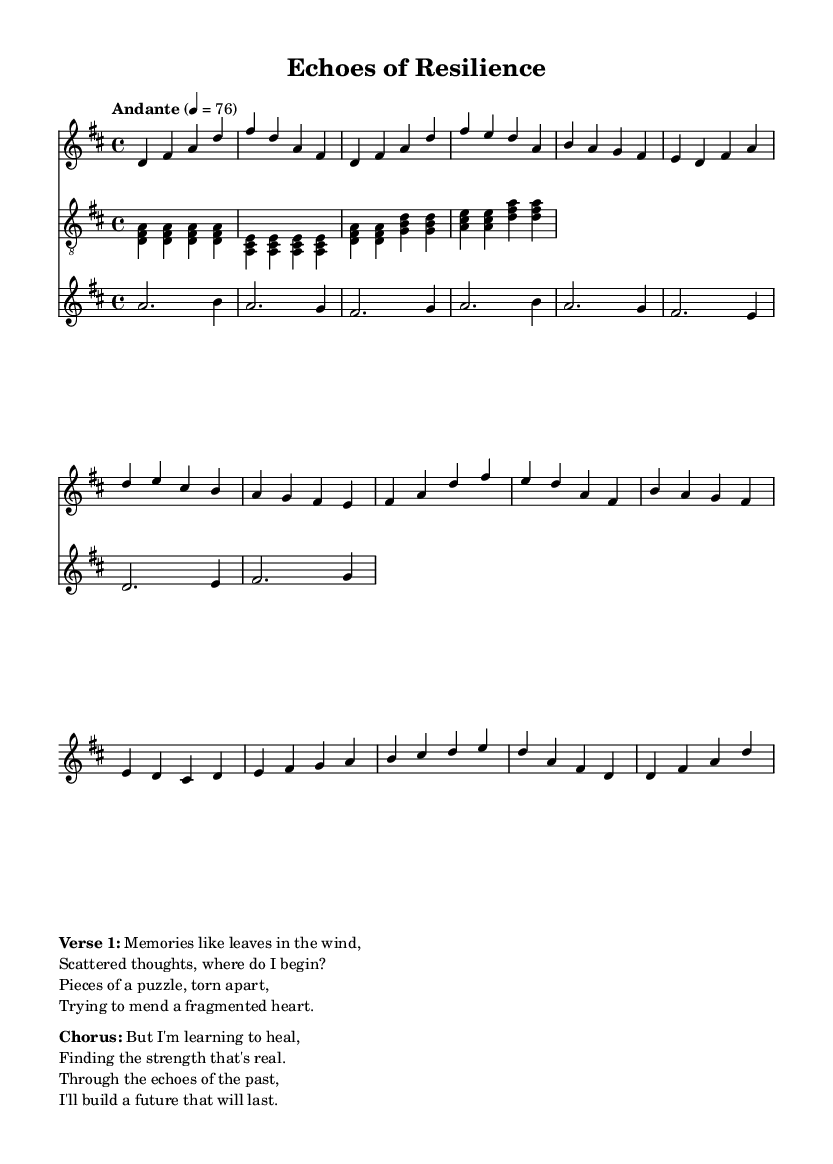What is the key signature of this music? The key signature is D major, which has two sharps: F# and C#. This can be identified in the global definition section where the key is set to D major.
Answer: D major What is the time signature of this music? The time signature is 4/4, which indicates that there are four beats in each measure, and the quarter note gets one beat. This is evident in the global section where the time signature is defined as 4/4.
Answer: 4/4 What is the tempo marking of this piece? The tempo marking is "Andante," which indicates a moderate pace. This is stated in the global section of the code after the tempo indication.
Answer: Andante How many measures are there in the verse section? The verse section consists of four measures, as it can be counted from the notes listed between the comments for the verse part in the voice declaration.
Answer: Four What is the first lyric line of the chorus? The first lyric line of the chorus is "But I'm learning to heal." This can be found directly in the markup section under the chorus part.
Answer: But I'm learning to heal Which instrument plays the simplified guitar part? The instrument that plays the simplified guitar part is the guitar, indicated in the score section where the staff labeled "guitar" includes the guitar music.
Answer: Guitar What emotional theme does the song convey? The emotional theme conveyed in the song revolves around self-discovery and healing, as reflected in the lyrics and title "Echoes of Resilience." This can be interpreted from the overall lyric content and song title provided in the markup section.
Answer: Self-discovery and healing 